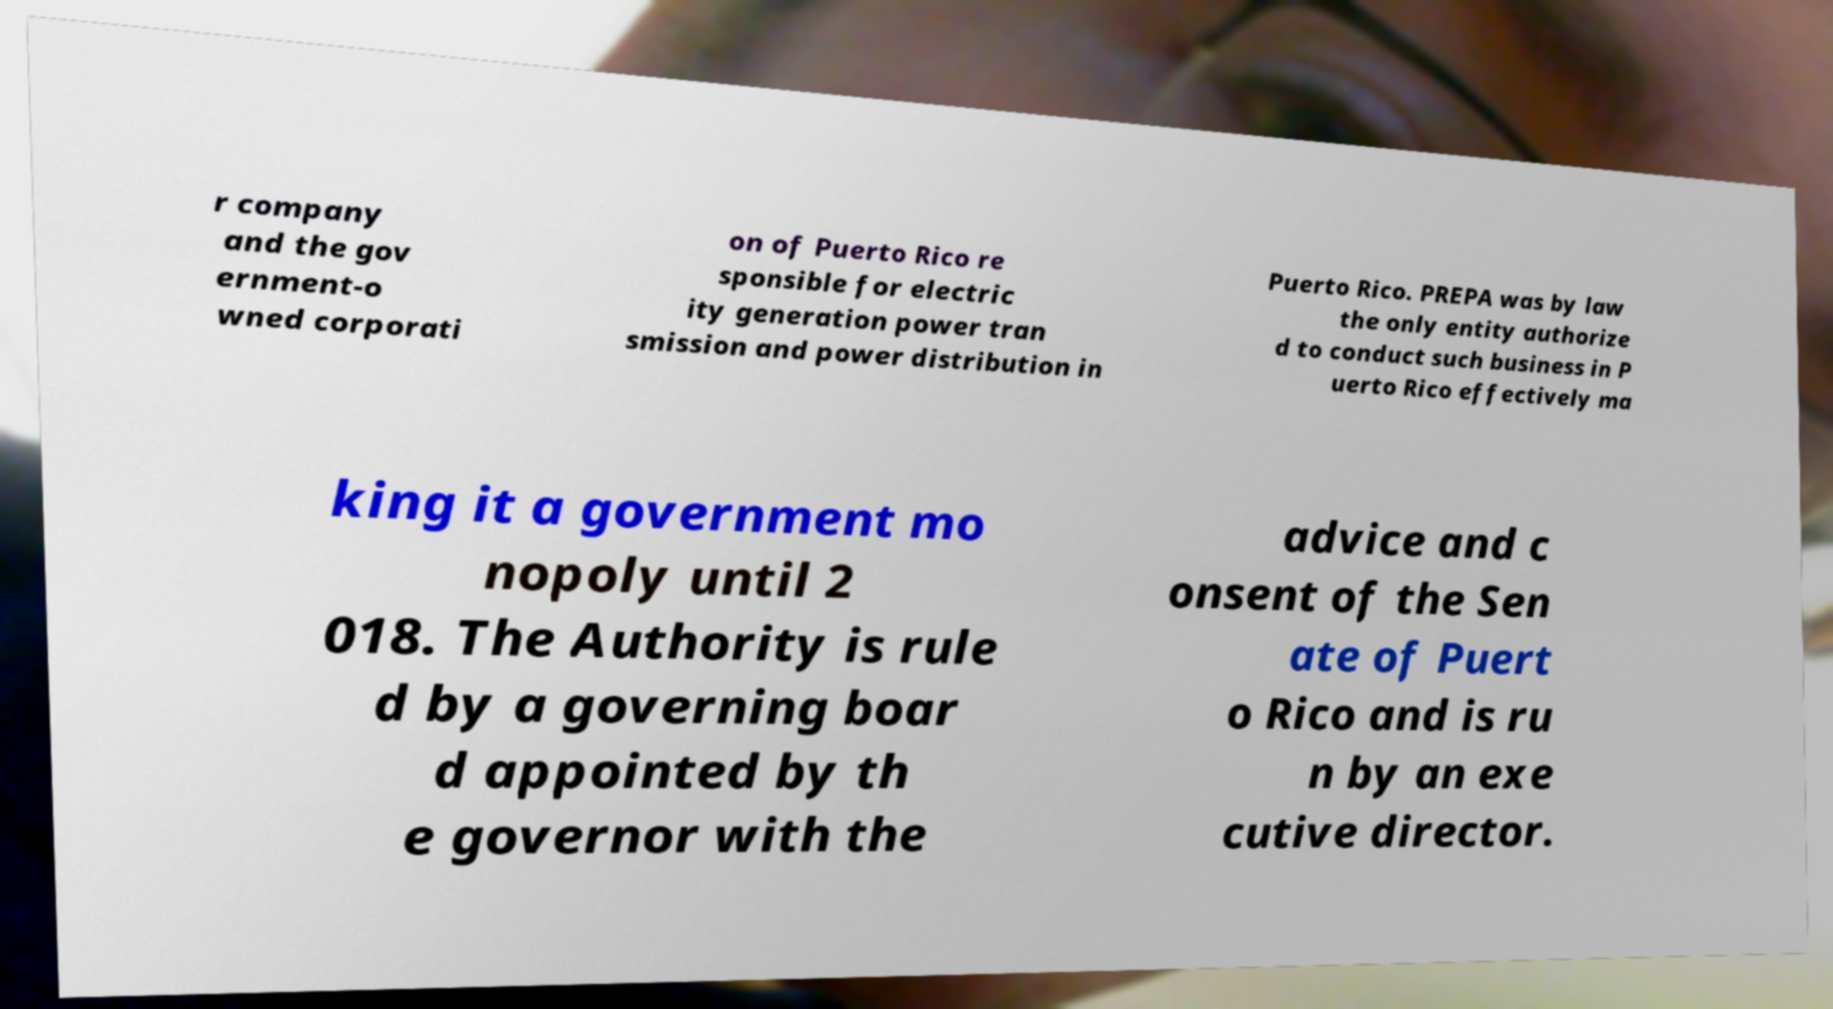Can you read and provide the text displayed in the image?This photo seems to have some interesting text. Can you extract and type it out for me? r company and the gov ernment-o wned corporati on of Puerto Rico re sponsible for electric ity generation power tran smission and power distribution in Puerto Rico. PREPA was by law the only entity authorize d to conduct such business in P uerto Rico effectively ma king it a government mo nopoly until 2 018. The Authority is rule d by a governing boar d appointed by th e governor with the advice and c onsent of the Sen ate of Puert o Rico and is ru n by an exe cutive director. 